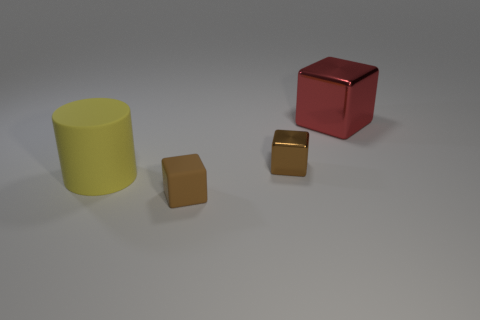Does the big red thing have the same material as the large cylinder?
Your answer should be compact. No. What number of shiny objects are behind the brown metallic object?
Make the answer very short. 1. What size is the red object that is the same shape as the tiny brown matte object?
Give a very brief answer. Large. What number of purple objects are either small things or matte objects?
Your answer should be very brief. 0. There is a big thing that is in front of the big red metal cube; how many big red things are behind it?
Ensure brevity in your answer.  1. How many other things are there of the same shape as the tiny brown rubber object?
Make the answer very short. 2. What is the material of the tiny thing that is the same color as the tiny shiny cube?
Your response must be concise. Rubber. How many tiny metallic blocks have the same color as the cylinder?
Keep it short and to the point. 0. What color is the other tiny cube that is the same material as the red block?
Offer a terse response. Brown. Is there a brown rubber thing of the same size as the red cube?
Keep it short and to the point. No. 